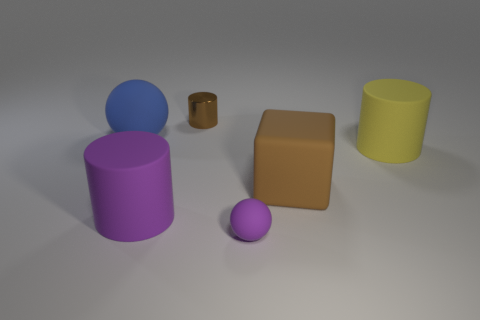Add 1 large blue rubber balls. How many objects exist? 7 Subtract all tiny brown cylinders. How many cylinders are left? 2 Subtract all yellow cylinders. How many cylinders are left? 2 Subtract all cyan blocks. Subtract all purple spheres. How many blocks are left? 1 Subtract all red cylinders. How many purple spheres are left? 1 Subtract all cyan shiny cylinders. Subtract all large things. How many objects are left? 2 Add 3 big matte cylinders. How many big matte cylinders are left? 5 Add 3 brown cylinders. How many brown cylinders exist? 4 Subtract 0 cyan balls. How many objects are left? 6 Subtract all spheres. How many objects are left? 4 